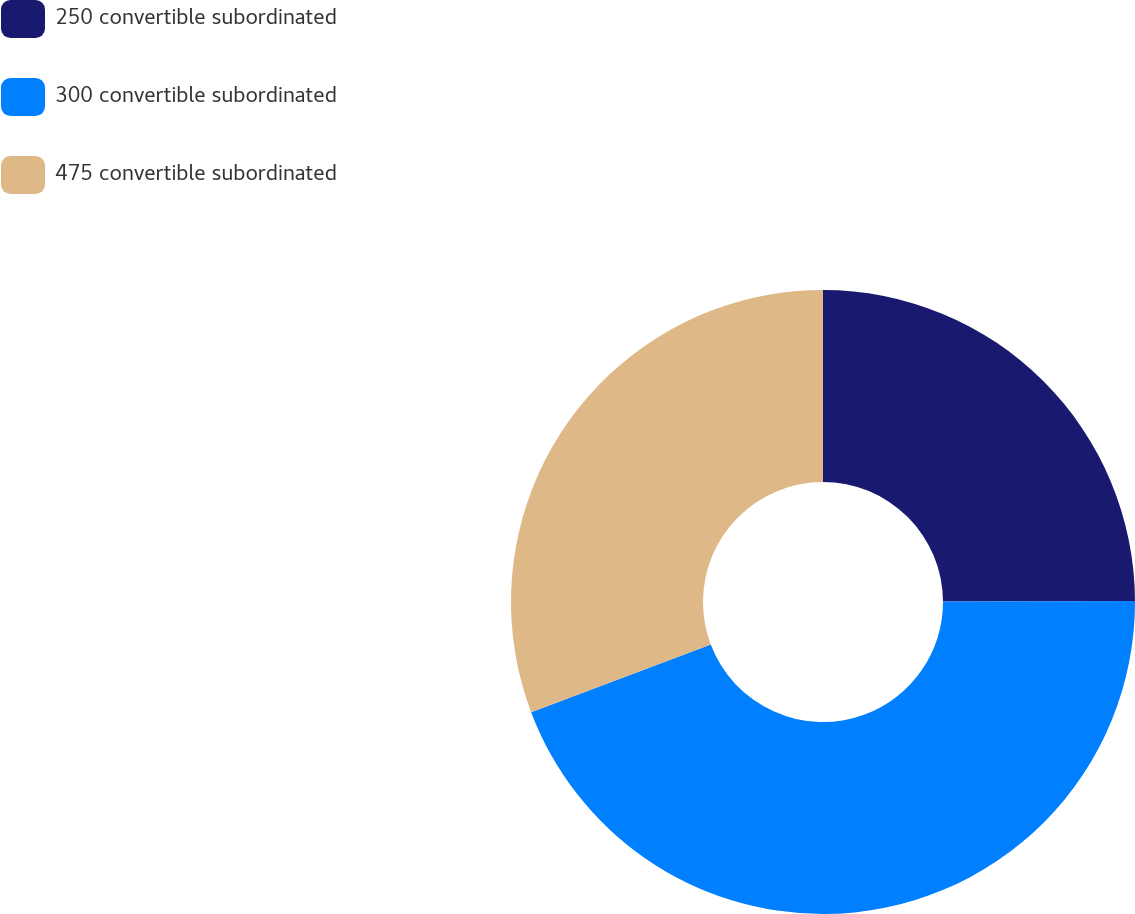Convert chart. <chart><loc_0><loc_0><loc_500><loc_500><pie_chart><fcel>250 convertible subordinated<fcel>300 convertible subordinated<fcel>475 convertible subordinated<nl><fcel>24.95%<fcel>44.31%<fcel>30.75%<nl></chart> 